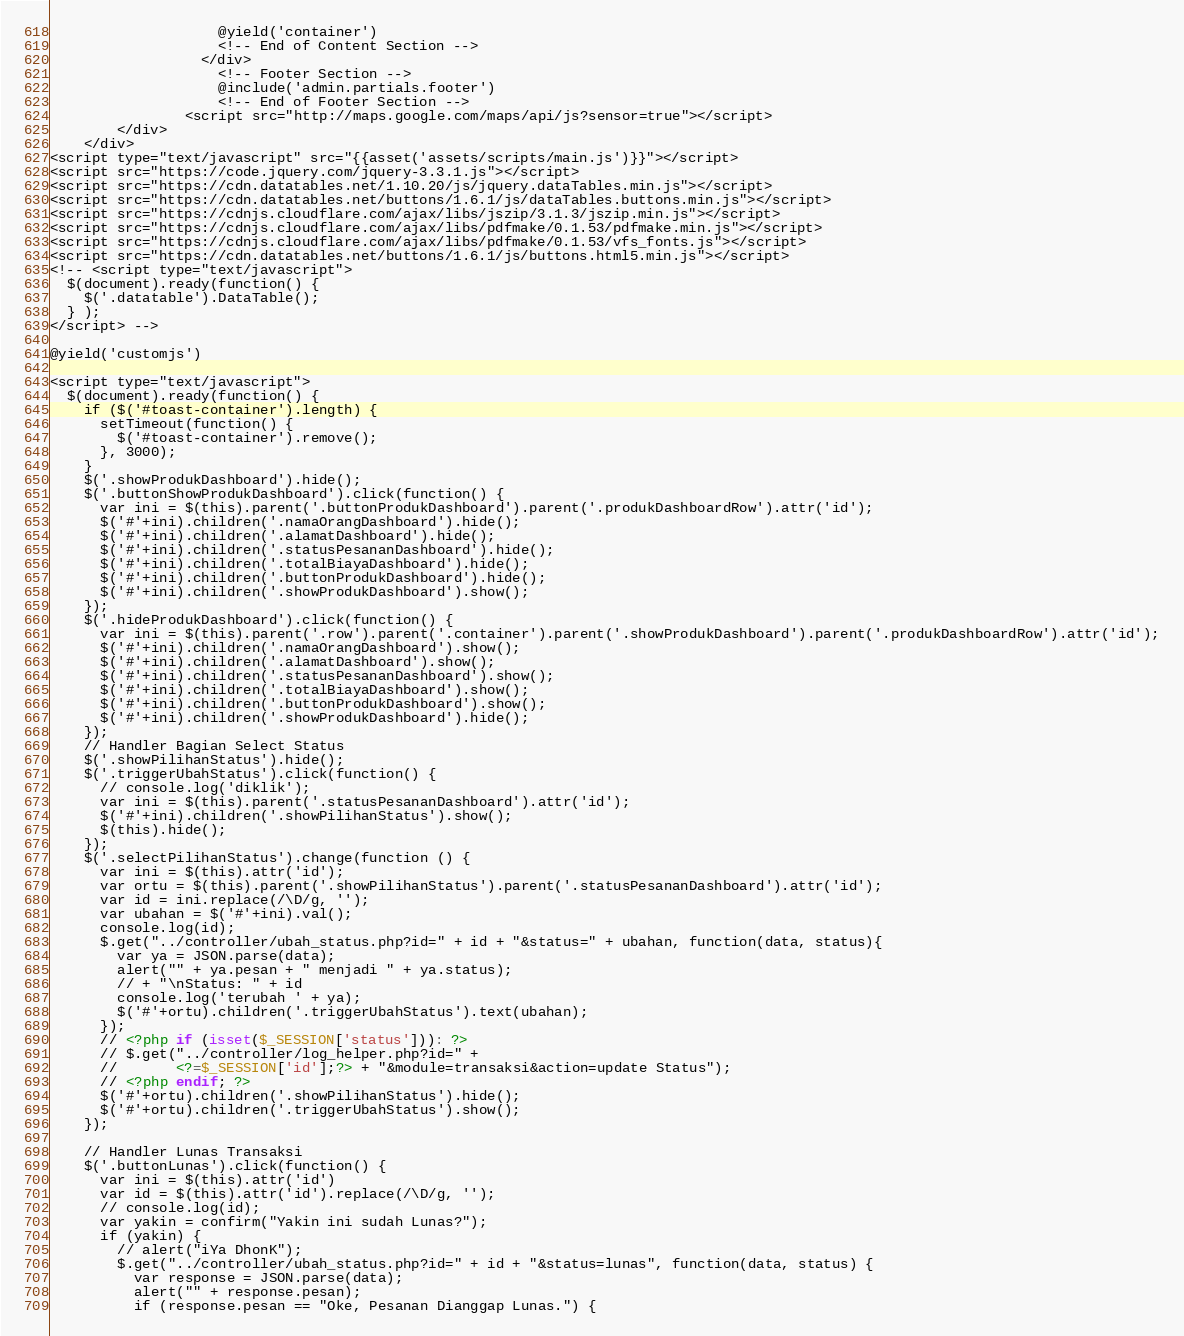Convert code to text. <code><loc_0><loc_0><loc_500><loc_500><_PHP_>                    @yield('container')
                    <!-- End of Content Section -->
                  </div>
                    <!-- Footer Section -->
                    @include('admin.partials.footer')
                    <!-- End of Footer Section -->
                <script src="http://maps.google.com/maps/api/js?sensor=true"></script>
        </div>
    </div>
<script type="text/javascript" src="{{asset('assets/scripts/main.js')}}"></script>
<script src="https://code.jquery.com/jquery-3.3.1.js"></script>
<script src="https://cdn.datatables.net/1.10.20/js/jquery.dataTables.min.js"></script>
<script src="https://cdn.datatables.net/buttons/1.6.1/js/dataTables.buttons.min.js"></script>
<script src="https://cdnjs.cloudflare.com/ajax/libs/jszip/3.1.3/jszip.min.js"></script>
<script src="https://cdnjs.cloudflare.com/ajax/libs/pdfmake/0.1.53/pdfmake.min.js"></script>
<script src="https://cdnjs.cloudflare.com/ajax/libs/pdfmake/0.1.53/vfs_fonts.js"></script>
<script src="https://cdn.datatables.net/buttons/1.6.1/js/buttons.html5.min.js"></script>
<!-- <script type="text/javascript">
  $(document).ready(function() {
    $('.datatable').DataTable();
  } );
</script> -->

@yield('customjs')

<script type="text/javascript">
  $(document).ready(function() {
    if ($('#toast-container').length) {
      setTimeout(function() {
        $('#toast-container').remove();
      }, 3000);
    }
    $('.showProdukDashboard').hide();
    $('.buttonShowProdukDashboard').click(function() {
      var ini = $(this).parent('.buttonProdukDashboard').parent('.produkDashboardRow').attr('id');
      $('#'+ini).children('.namaOrangDashboard').hide();
      $('#'+ini).children('.alamatDashboard').hide();
      $('#'+ini).children('.statusPesananDashboard').hide();
      $('#'+ini).children('.totalBiayaDashboard').hide();
      $('#'+ini).children('.buttonProdukDashboard').hide();
      $('#'+ini).children('.showProdukDashboard').show();
    });
    $('.hideProdukDashboard').click(function() {
      var ini = $(this).parent('.row').parent('.container').parent('.showProdukDashboard').parent('.produkDashboardRow').attr('id');
      $('#'+ini).children('.namaOrangDashboard').show();
      $('#'+ini).children('.alamatDashboard').show();
      $('#'+ini).children('.statusPesananDashboard').show();
      $('#'+ini).children('.totalBiayaDashboard').show();
      $('#'+ini).children('.buttonProdukDashboard').show();
      $('#'+ini).children('.showProdukDashboard').hide();
    });
    // Handler Bagian Select Status
    $('.showPilihanStatus').hide();
    $('.triggerUbahStatus').click(function() {
      // console.log('diklik');
      var ini = $(this).parent('.statusPesananDashboard').attr('id');
      $('#'+ini).children('.showPilihanStatus').show();
      $(this).hide();
    });
    $('.selectPilihanStatus').change(function () {
      var ini = $(this).attr('id');
      var ortu = $(this).parent('.showPilihanStatus').parent('.statusPesananDashboard').attr('id');
      var id = ini.replace(/\D/g, '');
      var ubahan = $('#'+ini).val();
      console.log(id);
      $.get("../controller/ubah_status.php?id=" + id + "&status=" + ubahan, function(data, status){
        var ya = JSON.parse(data);
        alert("" + ya.pesan + " menjadi " + ya.status);
        // + "\nStatus: " + id
        console.log('terubah ' + ya);
        $('#'+ortu).children('.triggerUbahStatus').text(ubahan);
      });
      // <?php if (isset($_SESSION['status'])): ?>
      // $.get("../controller/log_helper.php?id=" +
      //       <?=$_SESSION['id'];?> + "&module=transaksi&action=update Status");
      // <?php endif; ?>
      $('#'+ortu).children('.showPilihanStatus').hide();
      $('#'+ortu).children('.triggerUbahStatus').show();
    });

    // Handler Lunas Transaksi
    $('.buttonLunas').click(function() {
      var ini = $(this).attr('id')
      var id = $(this).attr('id').replace(/\D/g, '');
      // console.log(id);
      var yakin = confirm("Yakin ini sudah Lunas?");
      if (yakin) {
        // alert("iYa DhonK");
        $.get("../controller/ubah_status.php?id=" + id + "&status=lunas", function(data, status) {
          var response = JSON.parse(data);
          alert("" + response.pesan);
          if (response.pesan == "Oke, Pesanan Dianggap Lunas.") {</code> 